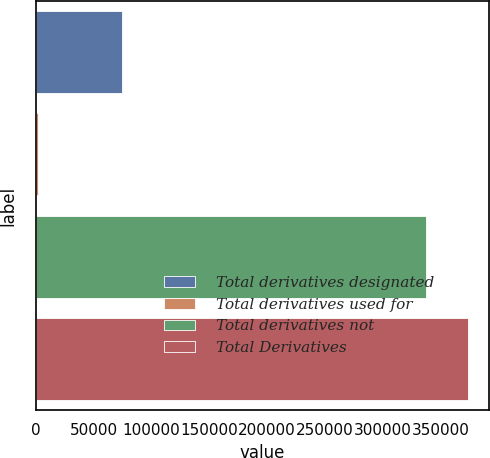Convert chart to OTSL. <chart><loc_0><loc_0><loc_500><loc_500><bar_chart><fcel>Total derivatives designated<fcel>Total derivatives used for<fcel>Total derivatives not<fcel>Total Derivatives<nl><fcel>74721.6<fcel>1813<fcel>337086<fcel>373540<nl></chart> 